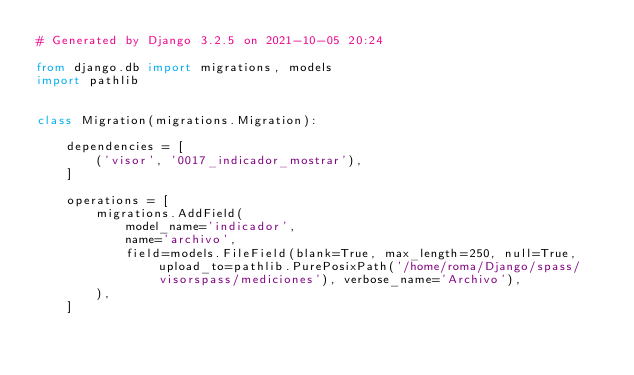Convert code to text. <code><loc_0><loc_0><loc_500><loc_500><_Python_># Generated by Django 3.2.5 on 2021-10-05 20:24

from django.db import migrations, models
import pathlib


class Migration(migrations.Migration):

    dependencies = [
        ('visor', '0017_indicador_mostrar'),
    ]

    operations = [
        migrations.AddField(
            model_name='indicador',
            name='archivo',
            field=models.FileField(blank=True, max_length=250, null=True, upload_to=pathlib.PurePosixPath('/home/roma/Django/spass/visorspass/mediciones'), verbose_name='Archivo'),
        ),
    ]
</code> 